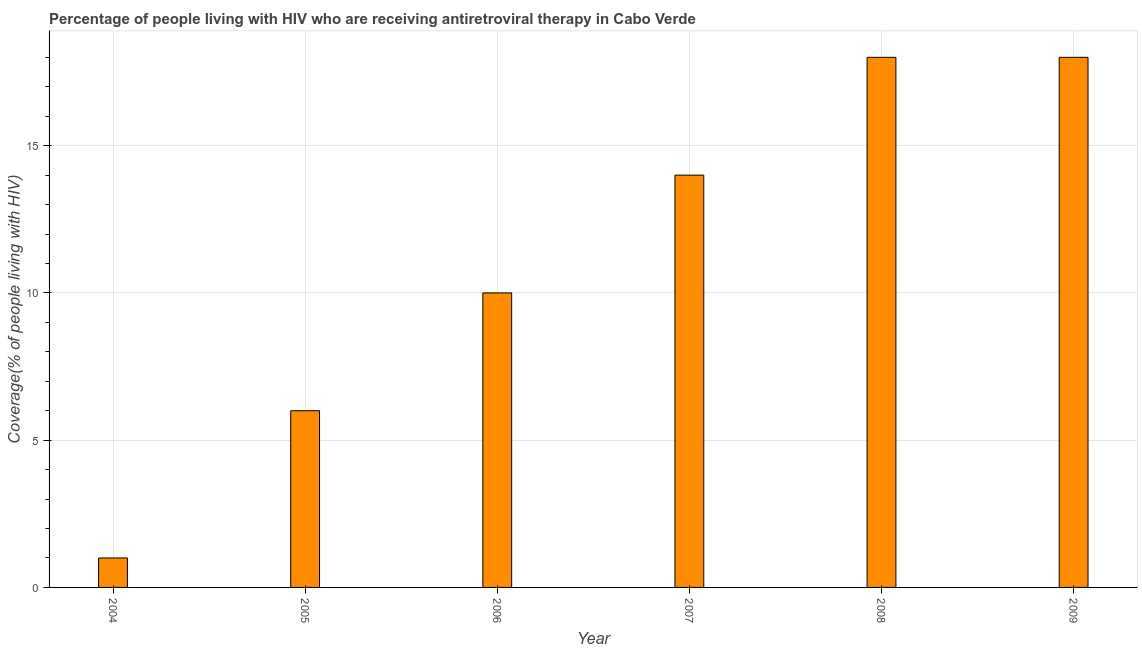What is the title of the graph?
Your answer should be very brief. Percentage of people living with HIV who are receiving antiretroviral therapy in Cabo Verde. What is the label or title of the X-axis?
Your answer should be very brief. Year. What is the label or title of the Y-axis?
Your answer should be compact. Coverage(% of people living with HIV). What is the antiretroviral therapy coverage in 2006?
Offer a very short reply. 10. Across all years, what is the minimum antiretroviral therapy coverage?
Your answer should be very brief. 1. In which year was the antiretroviral therapy coverage maximum?
Provide a succinct answer. 2008. Do a majority of the years between 2008 and 2005 (inclusive) have antiretroviral therapy coverage greater than 7 %?
Offer a terse response. Yes. What is the ratio of the antiretroviral therapy coverage in 2004 to that in 2005?
Your answer should be very brief. 0.17. Is the antiretroviral therapy coverage in 2005 less than that in 2006?
Provide a succinct answer. Yes. Is the difference between the antiretroviral therapy coverage in 2005 and 2006 greater than the difference between any two years?
Your answer should be compact. No. What is the difference between the highest and the second highest antiretroviral therapy coverage?
Provide a succinct answer. 0. Is the sum of the antiretroviral therapy coverage in 2005 and 2008 greater than the maximum antiretroviral therapy coverage across all years?
Provide a succinct answer. Yes. What is the difference between the highest and the lowest antiretroviral therapy coverage?
Offer a terse response. 17. In how many years, is the antiretroviral therapy coverage greater than the average antiretroviral therapy coverage taken over all years?
Your answer should be very brief. 3. How many years are there in the graph?
Offer a very short reply. 6. What is the Coverage(% of people living with HIV) in 2005?
Keep it short and to the point. 6. What is the Coverage(% of people living with HIV) in 2007?
Your answer should be very brief. 14. What is the Coverage(% of people living with HIV) of 2009?
Offer a very short reply. 18. What is the difference between the Coverage(% of people living with HIV) in 2004 and 2008?
Your answer should be compact. -17. What is the difference between the Coverage(% of people living with HIV) in 2005 and 2006?
Keep it short and to the point. -4. What is the difference between the Coverage(% of people living with HIV) in 2005 and 2007?
Provide a succinct answer. -8. What is the difference between the Coverage(% of people living with HIV) in 2005 and 2008?
Give a very brief answer. -12. What is the difference between the Coverage(% of people living with HIV) in 2005 and 2009?
Provide a short and direct response. -12. What is the difference between the Coverage(% of people living with HIV) in 2006 and 2008?
Your answer should be compact. -8. What is the difference between the Coverage(% of people living with HIV) in 2006 and 2009?
Keep it short and to the point. -8. What is the difference between the Coverage(% of people living with HIV) in 2007 and 2008?
Give a very brief answer. -4. What is the difference between the Coverage(% of people living with HIV) in 2008 and 2009?
Provide a succinct answer. 0. What is the ratio of the Coverage(% of people living with HIV) in 2004 to that in 2005?
Ensure brevity in your answer.  0.17. What is the ratio of the Coverage(% of people living with HIV) in 2004 to that in 2007?
Your answer should be very brief. 0.07. What is the ratio of the Coverage(% of people living with HIV) in 2004 to that in 2008?
Provide a succinct answer. 0.06. What is the ratio of the Coverage(% of people living with HIV) in 2004 to that in 2009?
Your answer should be very brief. 0.06. What is the ratio of the Coverage(% of people living with HIV) in 2005 to that in 2007?
Provide a short and direct response. 0.43. What is the ratio of the Coverage(% of people living with HIV) in 2005 to that in 2008?
Provide a succinct answer. 0.33. What is the ratio of the Coverage(% of people living with HIV) in 2005 to that in 2009?
Provide a succinct answer. 0.33. What is the ratio of the Coverage(% of people living with HIV) in 2006 to that in 2007?
Give a very brief answer. 0.71. What is the ratio of the Coverage(% of people living with HIV) in 2006 to that in 2008?
Make the answer very short. 0.56. What is the ratio of the Coverage(% of people living with HIV) in 2006 to that in 2009?
Offer a terse response. 0.56. What is the ratio of the Coverage(% of people living with HIV) in 2007 to that in 2008?
Your answer should be compact. 0.78. What is the ratio of the Coverage(% of people living with HIV) in 2007 to that in 2009?
Keep it short and to the point. 0.78. 